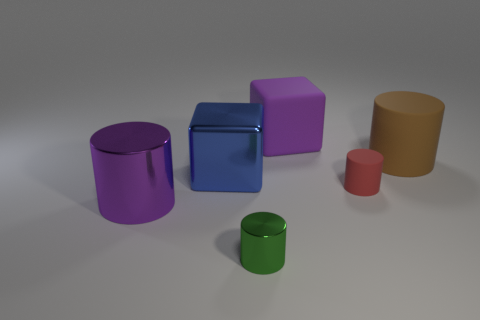Subtract 2 cylinders. How many cylinders are left? 2 Subtract all tiny shiny cylinders. How many cylinders are left? 3 Add 3 green shiny objects. How many objects exist? 9 Subtract all cubes. How many objects are left? 4 Subtract all gray cylinders. Subtract all purple spheres. How many cylinders are left? 4 Subtract all large blue things. Subtract all rubber blocks. How many objects are left? 4 Add 5 big blocks. How many big blocks are left? 7 Add 2 large things. How many large things exist? 6 Subtract 0 green cubes. How many objects are left? 6 